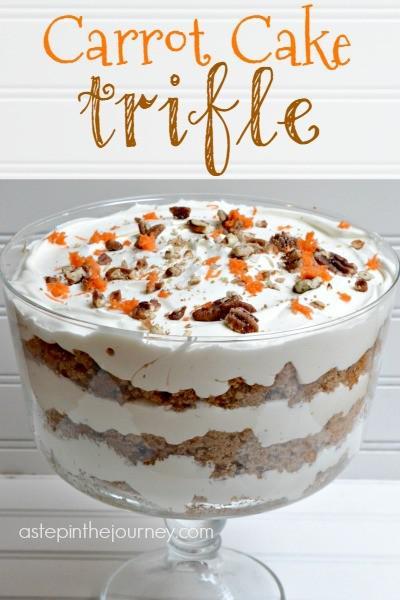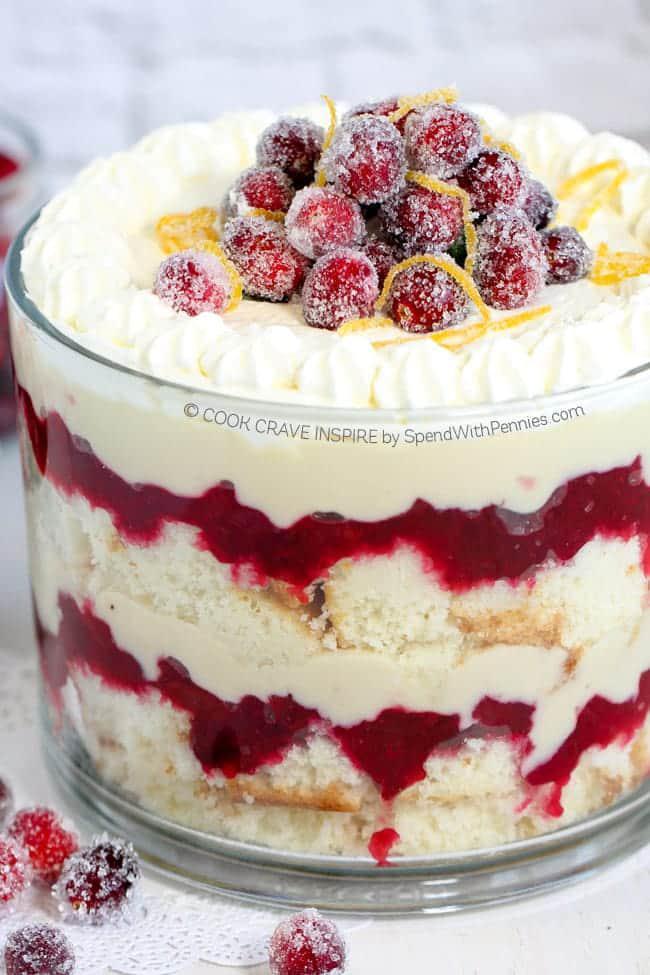The first image is the image on the left, the second image is the image on the right. Assess this claim about the two images: "An image shows a layered dessert served in a footed glass.". Correct or not? Answer yes or no. Yes. The first image is the image on the left, the second image is the image on the right. Examine the images to the left and right. Is the description "The dessert on the left does not contain any berries." accurate? Answer yes or no. Yes. 